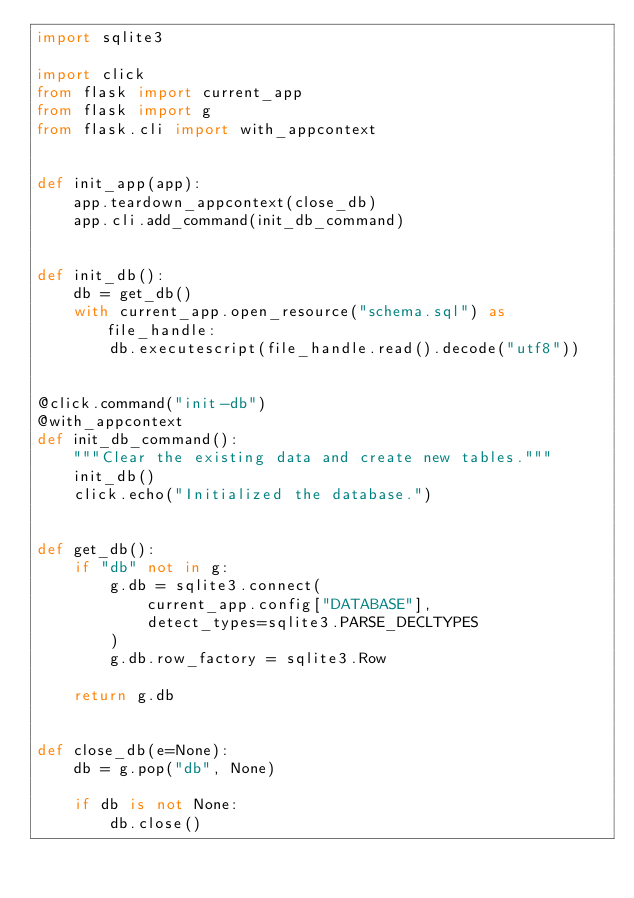<code> <loc_0><loc_0><loc_500><loc_500><_Python_>import sqlite3

import click
from flask import current_app
from flask import g
from flask.cli import with_appcontext


def init_app(app):
    app.teardown_appcontext(close_db)
    app.cli.add_command(init_db_command)


def init_db():
    db = get_db()
    with current_app.open_resource("schema.sql") as file_handle:
        db.executescript(file_handle.read().decode("utf8"))


@click.command("init-db")
@with_appcontext
def init_db_command():
    """Clear the existing data and create new tables."""
    init_db()
    click.echo("Initialized the database.")


def get_db():
    if "db" not in g:
        g.db = sqlite3.connect(
            current_app.config["DATABASE"],
            detect_types=sqlite3.PARSE_DECLTYPES
        )
        g.db.row_factory = sqlite3.Row

    return g.db


def close_db(e=None):
    db = g.pop("db", None)

    if db is not None:
        db.close()
</code> 